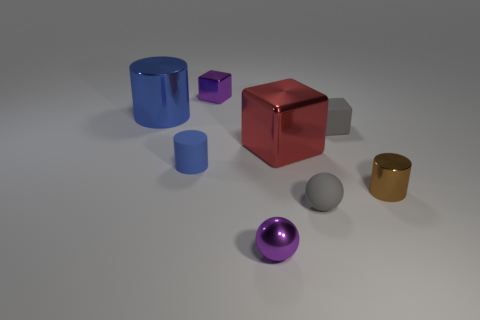Is the number of tiny matte objects greater than the number of big red cubes?
Provide a short and direct response. Yes. Do the gray thing that is in front of the small brown object and the brown thing have the same shape?
Your answer should be compact. No. What number of shiny objects are either brown things or small gray spheres?
Your answer should be compact. 1. Are there any blue cubes that have the same material as the tiny purple block?
Your response must be concise. No. What is the gray ball made of?
Offer a very short reply. Rubber. What is the shape of the blue thing that is in front of the big shiny cube on the right side of the purple metal thing in front of the purple cube?
Provide a short and direct response. Cylinder. Are there more big red shiny cubes right of the brown cylinder than red blocks?
Provide a succinct answer. No. Does the tiny blue object have the same shape as the tiny gray rubber thing that is behind the brown shiny cylinder?
Make the answer very short. No. What is the shape of the tiny matte thing that is the same color as the matte ball?
Make the answer very short. Cube. How many big things are on the left side of the large object that is on the right side of the tiny rubber thing that is to the left of the small matte ball?
Your answer should be very brief. 1. 